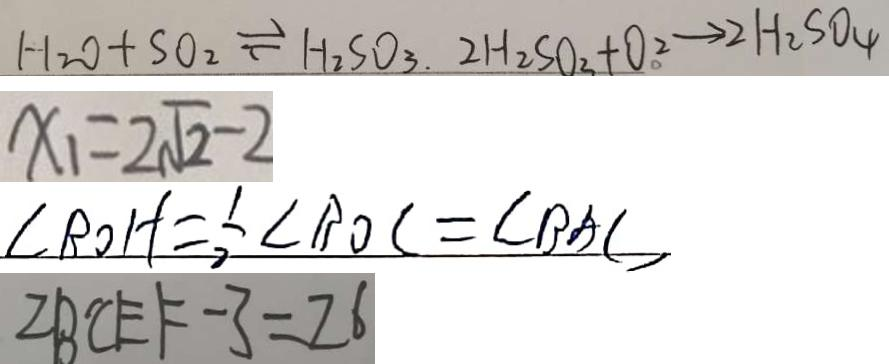Convert formula to latex. <formula><loc_0><loc_0><loc_500><loc_500>H _ { 2 } O + S 0 _ { 2 } \rightleftharpoons H _ { 2 } S O _ { 3 } . 2 H _ { 2 } S O _ { 3 } + O _ { \circ } ^ { 2 } \rightarrow 2 H _ { 2 } S O _ { 4 } 
 x _ { 1 } = 2 \sqrt { 2 } - 2 
 \angle B O H = \frac { 1 } { 2 } \angle B O C = \angle B A C 
 Z B ^ { \prime } C E F - 3 = 2 6</formula> 